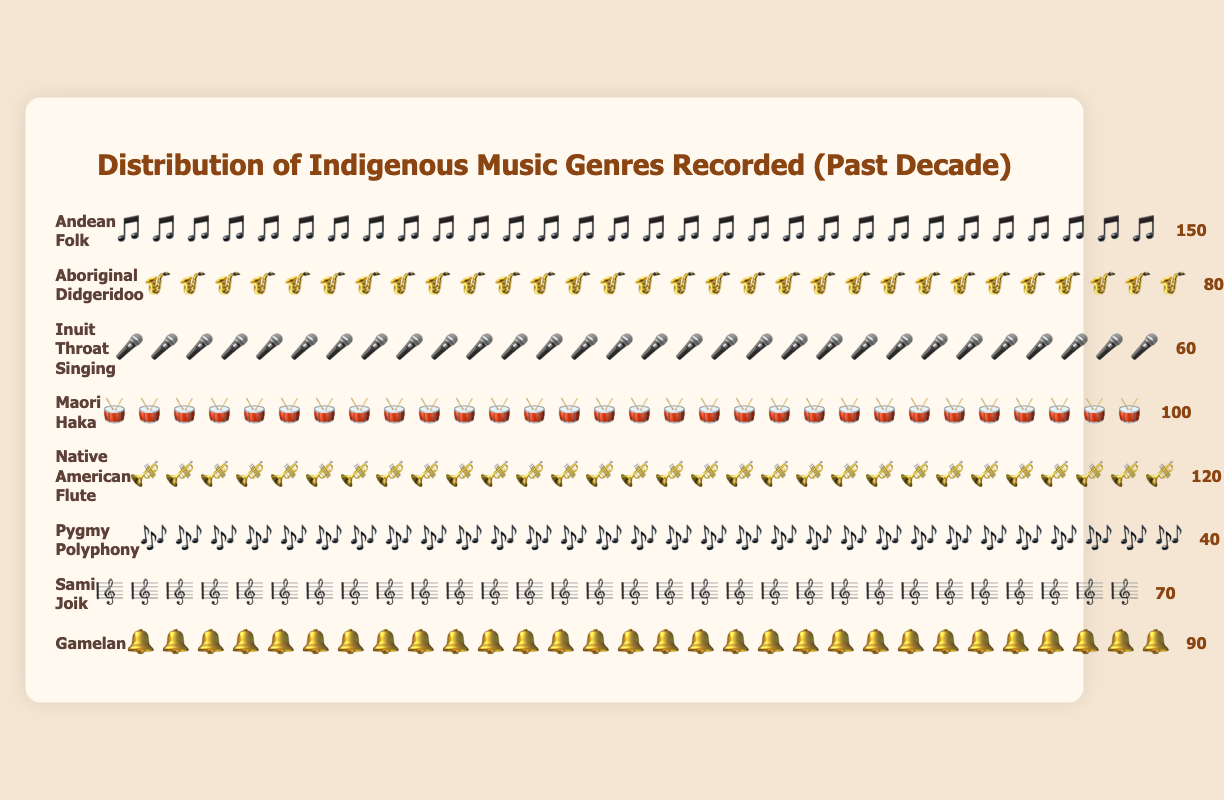Which genre has the highest number of recordings? To determine the genre with the highest number of recordings, look for the genre with the longest row of icons and the highest count number beside it. The count for "Andean Folk" is 150, which is the highest among all genres.
Answer: Andean Folk Which genre has the least number of recordings? To find the genre with the lowest number of recordings, look for the genre with the shortest row of icons and the lowest count number beside it. The count for "Pygmy Polyphony" is 40, which is the lowest among all genres.
Answer: Pygmy Polyphony How many more recordings does Native American Flute have compared to Gamelan? Native American Flute has 120 recordings and Gamelan has 90 recordings. By subtracting the number of recordings for Gamelan from those for Native American Flute (120 - 90), we find there are 30 more recordings for Native American Flute.
Answer: 30 What is the total number of recordings for all genres? Add the number of recordings for each genre: 150 (Andean Folk) + 80 (Aboriginal Didgeridoo) + 60 (Inuit Throat Singing) + 100 (Maori Haka) + 120 (Native American Flute) + 40 (Pygmy Polyphony) + 70 (Sami Joik) + 90 (Gamelan). The total sum is 710.
Answer: 710 Which genre has exactly 70 recordings? Look for the genre with a count of 70 next to it. The genre with 70 recordings is "Sami Joik".
Answer: Sami Joik Which genres have more than 100 recordings? Identify the genres with a count number higher than 100. The genres are Andean Folk (150), Native American Flute (120), and Maori Haka (100).
Answer: Andean Folk, Native American Flute, Maori Haka What is the average number of recordings per genre? To find the average, divide the total number of recordings (710) by the number of genres (8): 710 / 8 = 88.75.
Answer: 88.75 How many genres have fewer than 100 recordings? Identify the genres with a count number less than 100. The genres are Aboriginal Didgeridoo, Inuit Throat Singing, Pygmy Polyphony, Sami Joik, and Gamelan. Counting these gives a total of 5 genres.
Answer: 5 Which genre has twice the number of recordings as Inuit Throat Singing? Inuit Throat Singing has 60 recordings. Twice this amount is 60 * 2 = 120. The genre with 120 recordings is Native American Flute.
Answer: Native American Flute How many recordings in total do the genres with fewer than 70 recordings have? Identify the genres with fewer than 70 recordings: Inuit Throat Singing (60) and Pygmy Polyphony (40). Sum these up: 60 + 40 = 100.
Answer: 100 